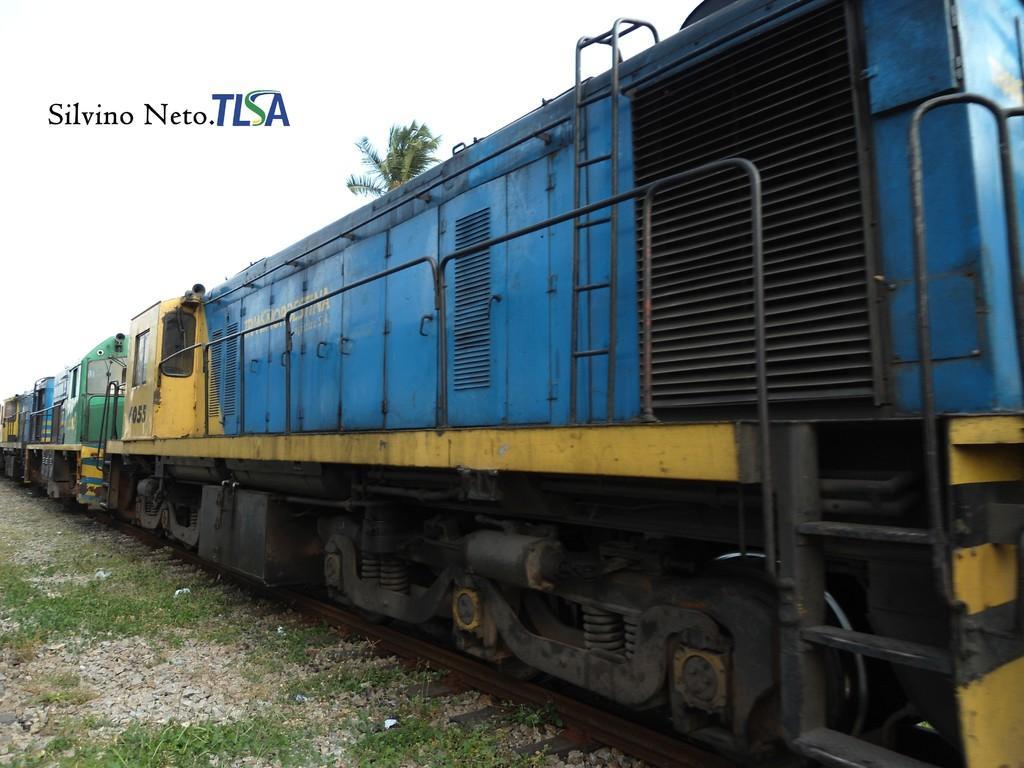Please provide a concise description of this image. In this image I can see the train on the track. To the left I can see the grass and rocks. In the background I can see the tree and the sky. I can see something is written on the image. 